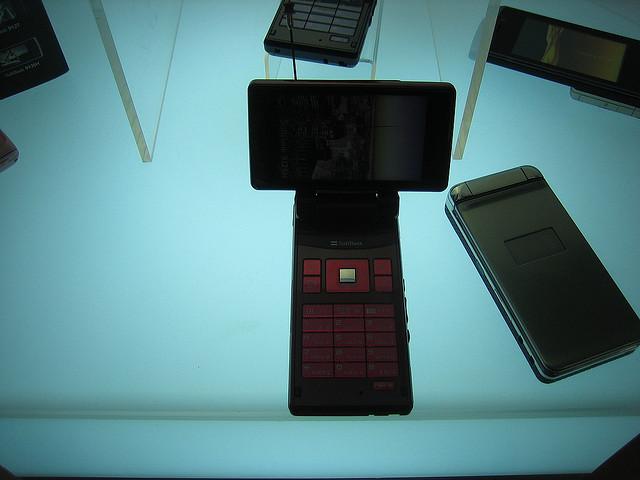What is the rectangular thing called?
Be succinct. Phone. What is the name on the phone?
Quick response, please. Nokia. What color are the buttons on the main phone?
Give a very brief answer. Red. Is there an iPhone on the table?
Be succinct. No. 